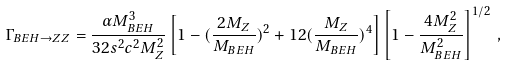<formula> <loc_0><loc_0><loc_500><loc_500>\Gamma _ { B E H \to Z Z } = \frac { \alpha M _ { B E H } ^ { 3 } } { 3 2 s ^ { 2 } c ^ { 2 } M _ { Z } ^ { 2 } } \left [ 1 - ( \frac { 2 M _ { Z } } { M _ { B E H } } ) ^ { 2 } + 1 2 ( \frac { M _ { Z } } { M _ { B E H } } ) ^ { 4 } \right ] \left [ 1 - \frac { 4 M _ { Z } ^ { 2 } } { M _ { B E H } ^ { 2 } } \right ] ^ { 1 / 2 } \, ,</formula> 